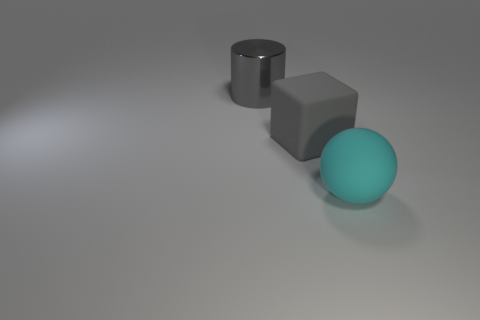Can you speculate on the purpose of these objects? Are they functional or purely decorative? These objects, due to their simplistic nature and the context of the image, likely serve as visual aids or examples in a study of geometry, light, and shadows. They seem to be more illustrative or decorative as there is no clear indication that they have any functional purpose beyond their appearance in the image. 